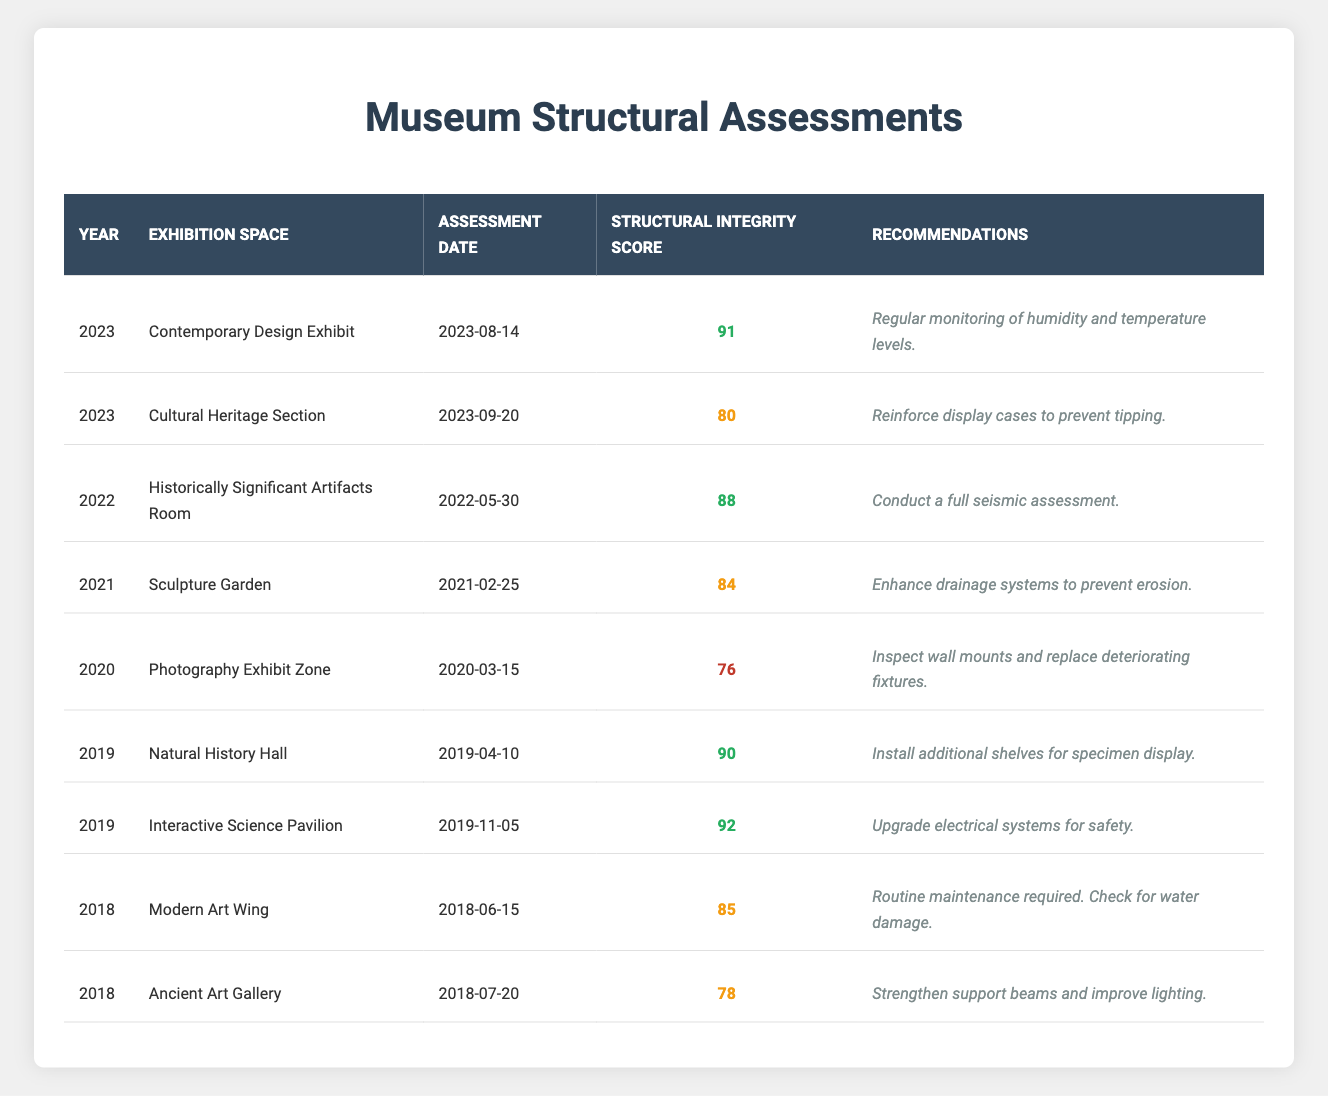What is the structural integrity score of the Contemporary Design Exhibit? The table shows that the structural integrity score for the Contemporary Design Exhibit in 2023 is 91.
Answer: 91 What recommendations were made for the Cultural Heritage Section? The table indicates that the recommendations for the Cultural Heritage Section are to reinforce display cases to prevent tipping.
Answer: Reinforce display cases to prevent tipping Which exhibition space received the highest structural integrity score in 2019? In 2019, the table shows that the Interactive Science Pavilion had the highest score of 92.
Answer: Interactive Science Pavilion What is the average structural integrity score for the year 2022? The only assessment listed for the year 2022 is for the Historically Significant Artifacts Room, which has a score of 88, making the average for that year also 88.
Answer: 88 Did any exhibition space assessments conducted in 2020 have a score above 80? The table shows that the Photography Exhibit Zone, assessed in 2020, has a score of 76, which is below 80. So, no exhibition space had a score above 80 that year.
Answer: No What is the difference between the highest and lowest structural integrity scores in 2023? The highest score in 2023 is 91 (Contemporary Design Exhibit) and the lowest is 80 (Cultural Heritage Section). The difference is 91 - 80 = 11.
Answer: 11 Which exhibition space required routine maintenance in 2018, and what was its score? In 2018, the Modern Art Wing required routine maintenance, and its structural integrity score was 85.
Answer: Modern Art Wing, 85 How many exhibition spaces had a score below 80 across all years? From the table, only the Photography Exhibit Zone in 2020 had a score below 80 (76). Thus, there is 1 exhibition space.
Answer: 1 What is the trend in structural integrity scores from 2018 to 2023? Reviewing the scores from the table: 2018 (85, 78), 2019 (90, 92), 2020 (76), 2021 (84), 2022 (88), and 2023 (91, 80), we see a general increase with a dip in 2020 and then a recovery leading to 2023.
Answer: General increase with a dip in 2020 Which year had the most assessments listed? The table shows assessments for 2018 (2), 2019 (2), 2020 (1), 2021 (1), 2022 (1), and 2023 (2). Therefore, 2018, 2019, and 2023 each had 2 assessments, making them tie for the most.
Answer: 2018, 2019, 2023 